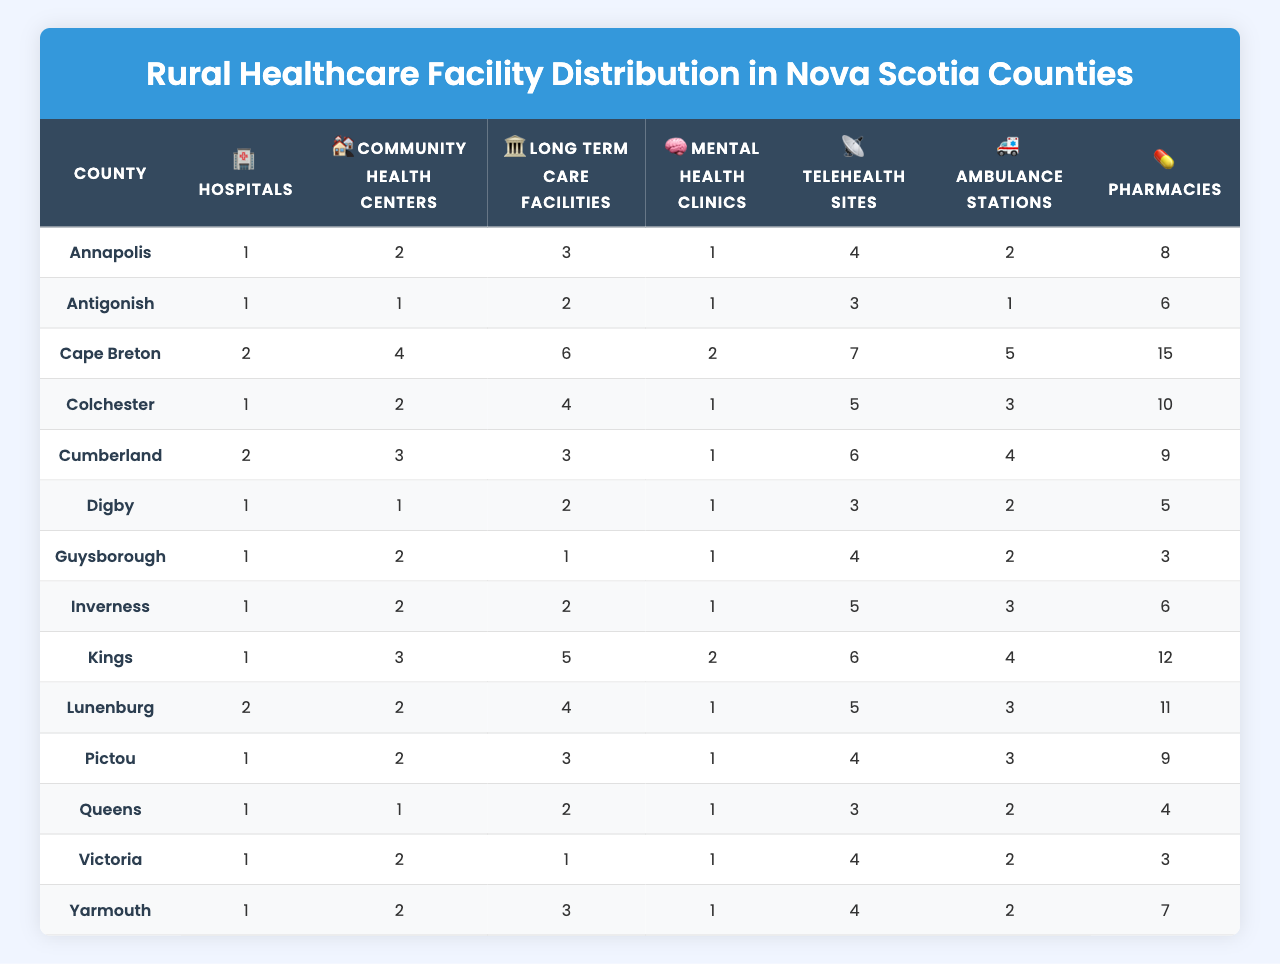What is the county with the highest number of hospitals? By examining the "Hospitals" column in the table, Cape Breton has the highest value at 2 hospitals, while all other counties have 1 or 0.
Answer: Cape Breton How many community health centers are there in Colchester? The "Community Health Centers" column for Colchester shows a value of 2.
Answer: 2 Which county has the least number of pharmacies? Looking at the "Pharmacies" column, Guysborough has the smallest value, which is 3 pharmacies.
Answer: Guysborough What is the total number of long-term care facilities across all counties? By summing the values in the "Long Term Care Facilities" column (3 + 2 + 6 + 4 + 3 + 2 + 1 + 2 + 5 + 4 + 3 + 2 + 1 + 3 = 43), we find the total is 43.
Answer: 43 Are there more mental health clinics in Yarmouth than in Digby? Comparing the values in the "Mental Health Clinics" column, both Yarmouth and Digby have 1 clinic each, so the statement is false.
Answer: No What is the average number of telehealth sites in all the counties? We sum the "Telehealth Sites" values (4 + 3 + 7 + 5 + 6 + 3 + 4 + 5 + 6 + 5 + 4 + 3 + 4 + 4 = 58) and divide by the number of counties (14), which gives 58/14 = 4.14, rounded to two decimal places gives 4.14.
Answer: 4.14 Which county has the most ambulance stations? Examining the "Ambulance Stations" column, Cape Breton has the most at 5 stations, more than any other county.
Answer: Cape Breton What is the difference in the number of hospitals between Kings and Cumberland? From the table, Kings has 1 hospital and Cumberland has 2 hospitals, creating a difference of 2 - 1 = 1.
Answer: 1 How many counties have more than 10 pharmacies? Only Cape Breton (15) and Kings (12) have more than 10 pharmacies, which means there are 2 counties meeting this criterion.
Answer: 2 Is the number of long-term care facilities in Kings greater than that in Inverness? Kings has 5 long-term care facilities while Inverness has only 2, thus the statement is true.
Answer: Yes What proportion of counties have at least 2 community health centers? There are 6 counties (Cape Breton, Cumberland, Kings, Lunenburg, and Colchester) with at least 2 community health centers. Since there are 14 counties in total, the proportion is 6/14 = 0.43.
Answer: 0.43 